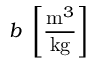Convert formula to latex. <formula><loc_0><loc_0><loc_500><loc_500>b \left [ \frac { m ^ { 3 } } { k g } \right ]</formula> 